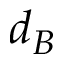<formula> <loc_0><loc_0><loc_500><loc_500>d _ { B }</formula> 